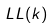<formula> <loc_0><loc_0><loc_500><loc_500>L L ( k )</formula> 